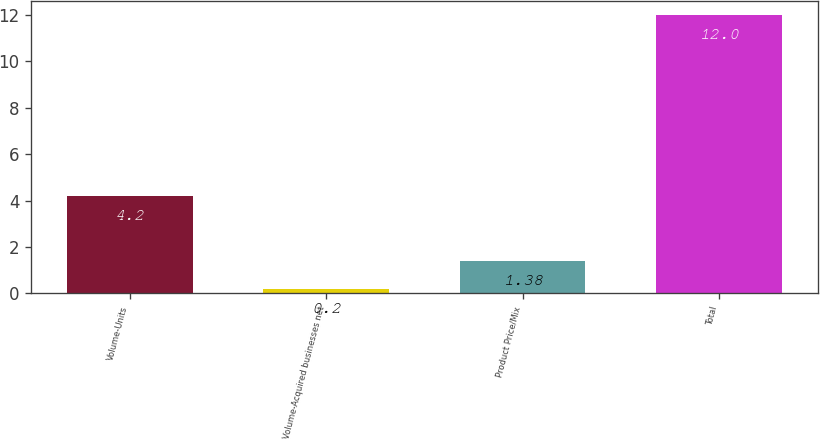Convert chart to OTSL. <chart><loc_0><loc_0><loc_500><loc_500><bar_chart><fcel>Volume-Units<fcel>Volume-Acquired businesses net<fcel>Product Price/Mix<fcel>Total<nl><fcel>4.2<fcel>0.2<fcel>1.38<fcel>12<nl></chart> 